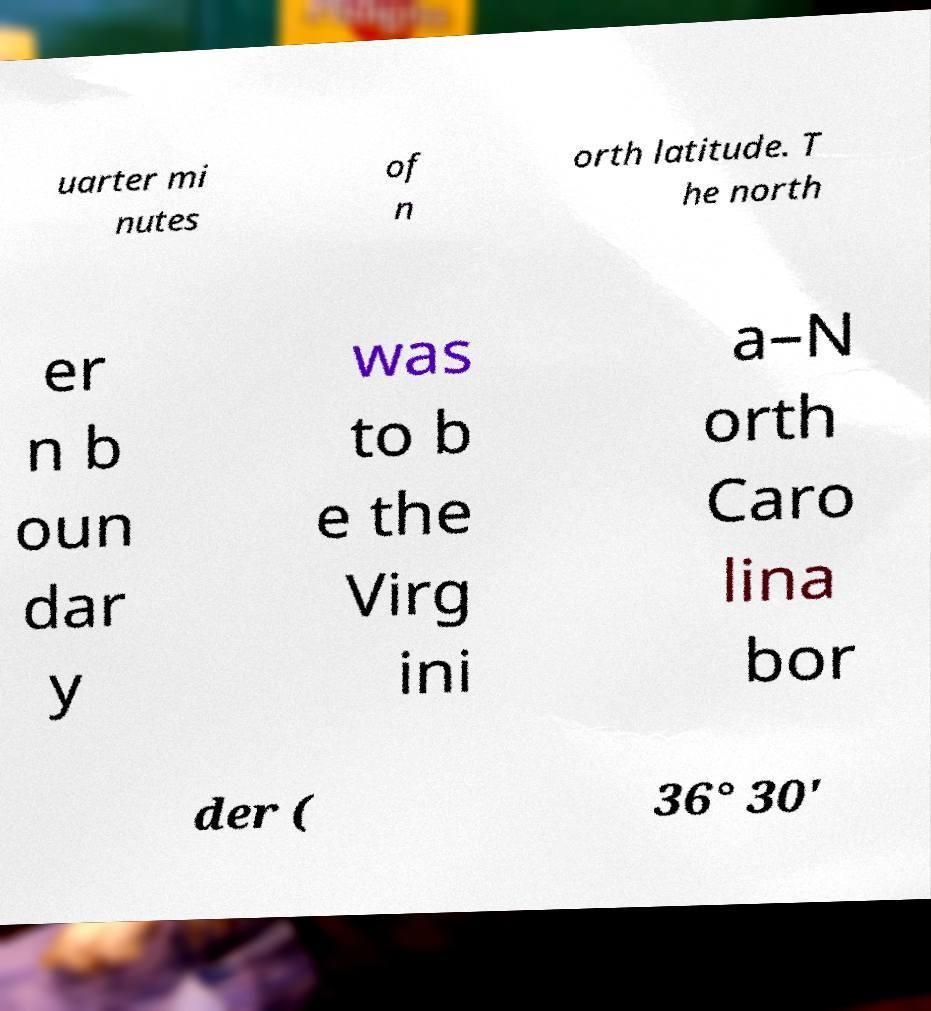What messages or text are displayed in this image? I need them in a readable, typed format. uarter mi nutes of n orth latitude. T he north er n b oun dar y was to b e the Virg ini a–N orth Caro lina bor der ( 36° 30' 